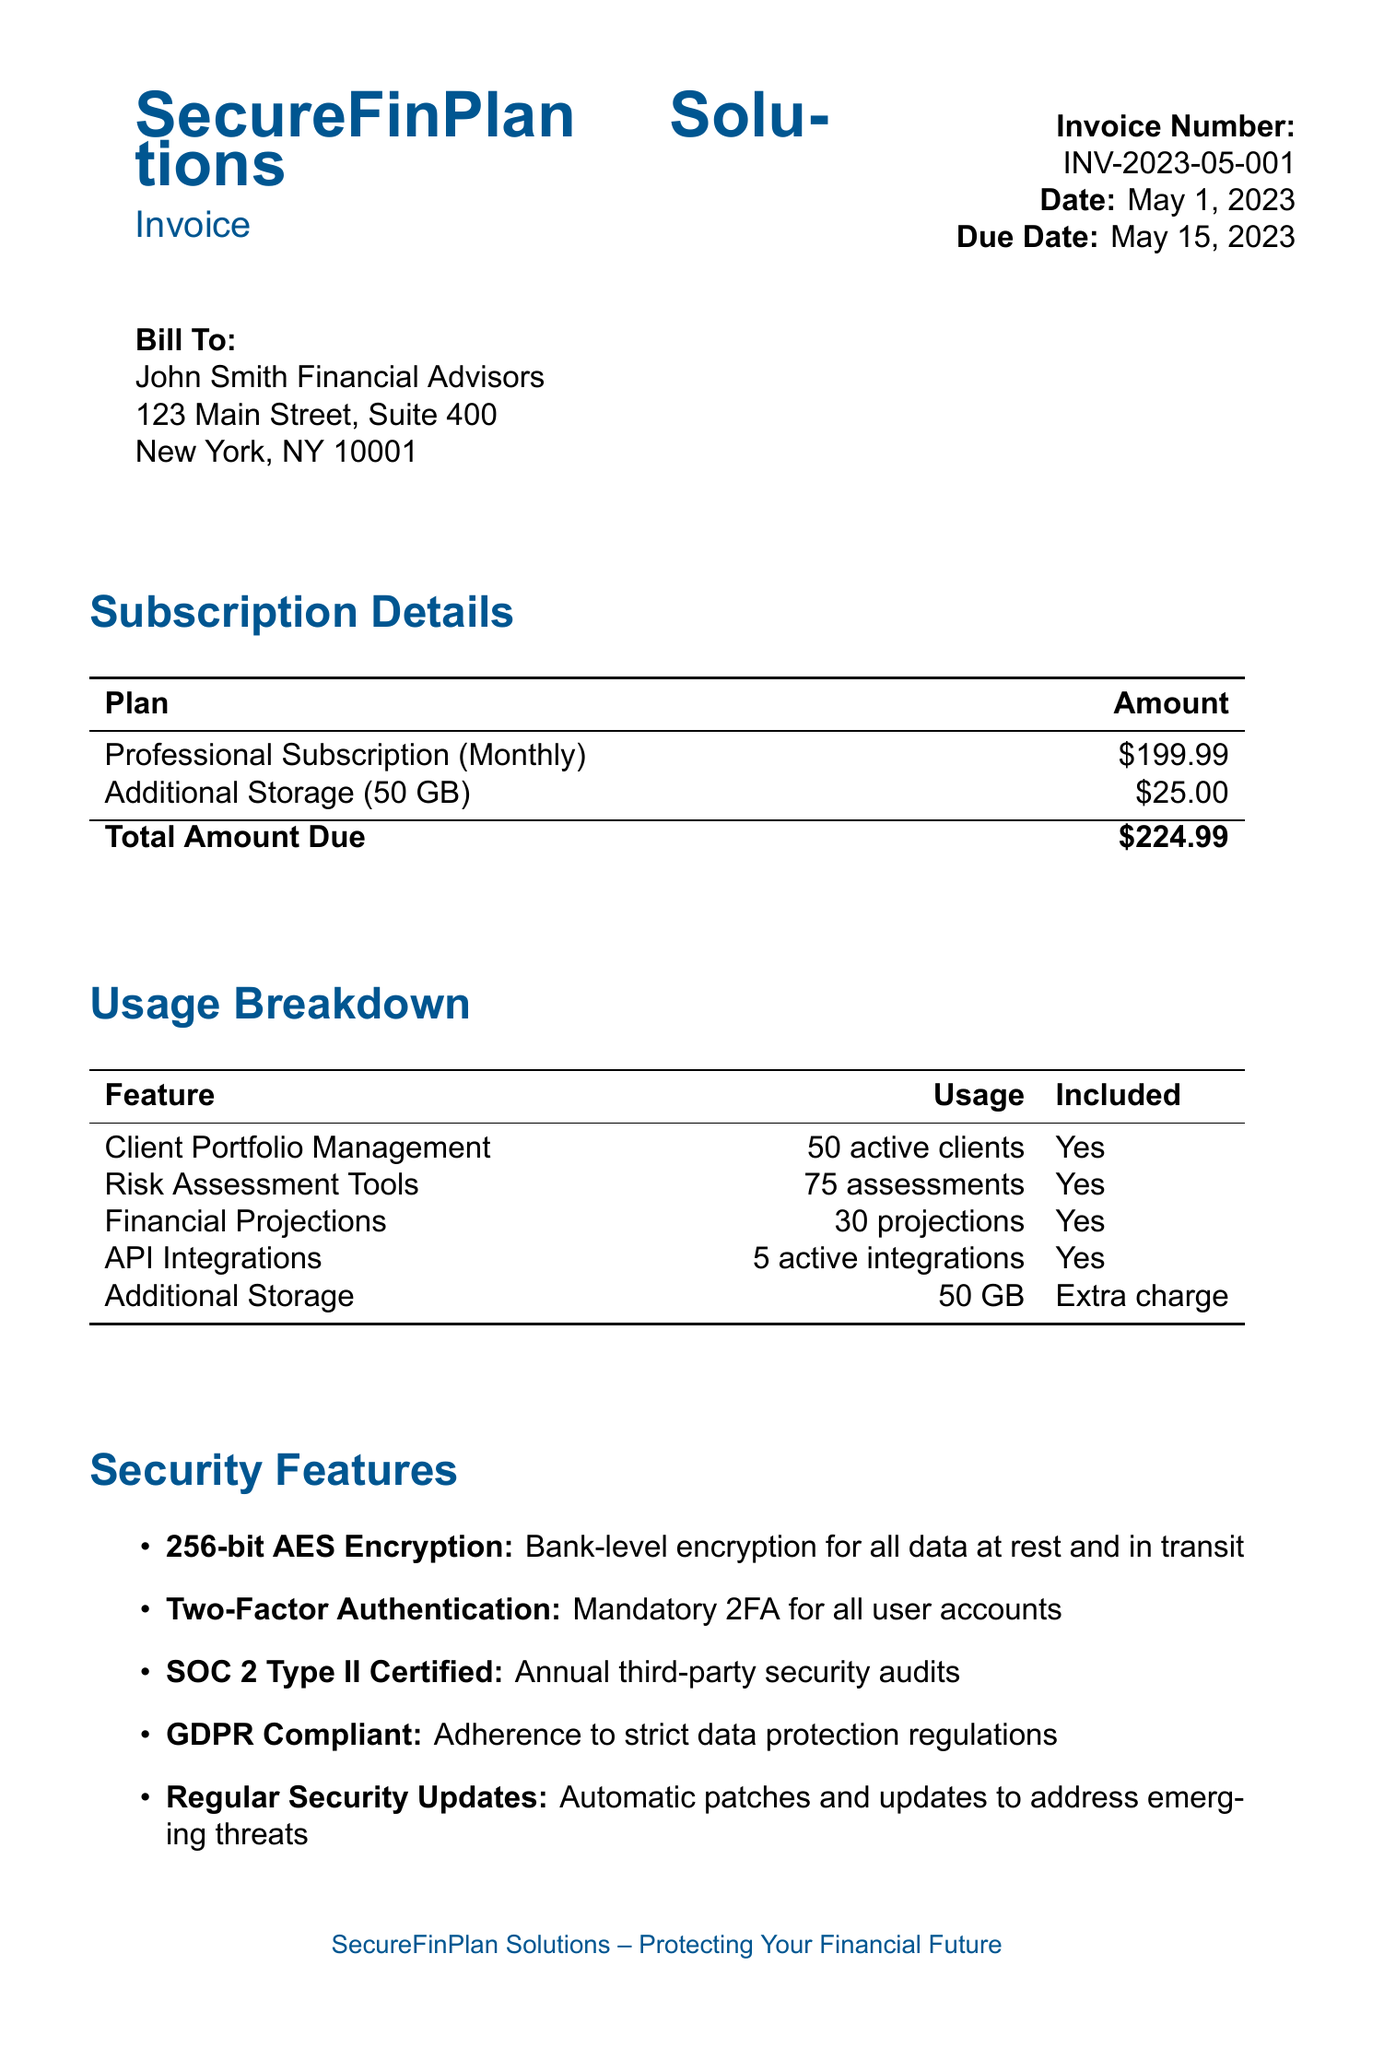What is the company name? The company name is clearly stated at the top of the document.
Answer: SecureFinPlan Solutions What is the invoice number? The invoice number can be found in the header section of the document.
Answer: INV-2023-05-001 What is the due date for payment? The due date is specified in the document's header section.
Answer: May 15, 2023 How much is the monthly fee for the subscription plan? The monthly fee is listed under the subscription details section of the document.
Answer: $199.99 What additional cost is listed for storage? The document itemizes the additional cost for storage under the subscription details.
Answer: $25.00 How many risk assessments were used? The usage breakdown specifies the number of assessments used.
Answer: 75 assessments What security feature ensures mandatory account protection? The security features section describes mandatory protections.
Answer: Two-Factor Authentication What type of certification is mentioned for security audits? The document specifies the type of certification related to security audits.
Answer: SOC 2 Type II Certified What payment method is provided for ACH transfers? Payment methods section lists specifics about ACH transfers.
Answer: Account ending in 9876 